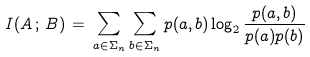Convert formula to latex. <formula><loc_0><loc_0><loc_500><loc_500>I ( A \, ; \, B ) \, = \, \sum _ { a \in \Sigma _ { n } } \sum _ { b \in \Sigma _ { n } } p ( a , b ) \log _ { 2 } \frac { p ( a , b ) } { p ( a ) p ( b ) }</formula> 